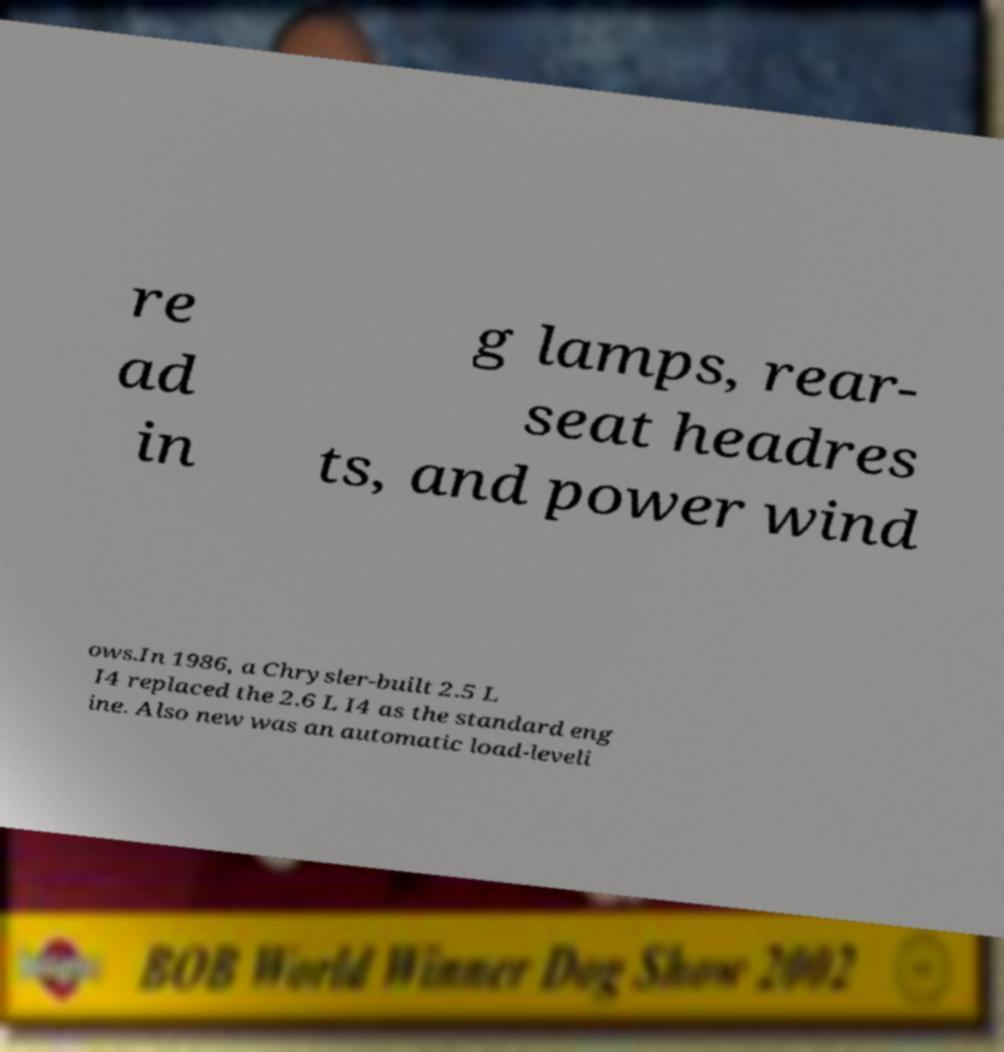For documentation purposes, I need the text within this image transcribed. Could you provide that? re ad in g lamps, rear- seat headres ts, and power wind ows.In 1986, a Chrysler-built 2.5 L I4 replaced the 2.6 L I4 as the standard eng ine. Also new was an automatic load-leveli 